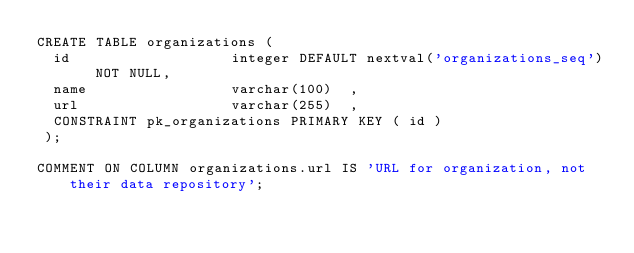<code> <loc_0><loc_0><loc_500><loc_500><_SQL_>CREATE TABLE organizations ( 
	id                   integer DEFAULT nextval('organizations_seq') NOT NULL,
	name                 varchar(100)  ,
	url                  varchar(255)  ,
	CONSTRAINT pk_organizations PRIMARY KEY ( id )
 );

COMMENT ON COLUMN organizations.url IS 'URL for organization, not their data repository';</code> 